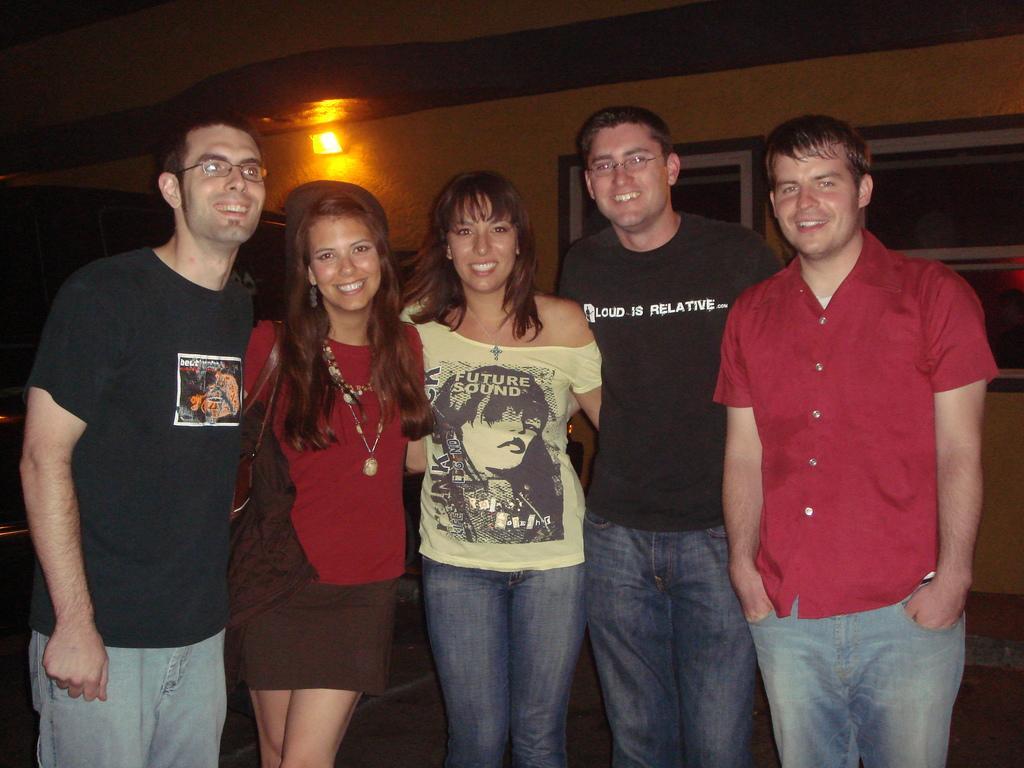Can you describe this image briefly? In this image in the center there are a group of people who are standing and smiling, and in the background there are some photo frames on the wall and light and wall. At the bottom there is floor. 